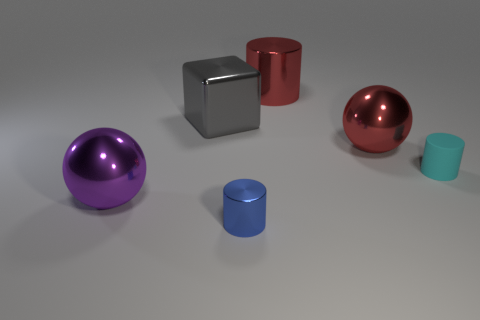What size is the metal sphere that is the same color as the large metallic cylinder?
Make the answer very short. Large. Is the number of rubber things left of the big purple sphere the same as the number of gray blocks to the right of the tiny cyan matte cylinder?
Provide a short and direct response. Yes. What is the size of the metallic ball that is to the right of the tiny blue metal object?
Your response must be concise. Large. The small thing that is behind the tiny blue cylinder that is in front of the large purple metallic thing is made of what material?
Provide a succinct answer. Rubber. What number of large red balls are in front of the big sphere that is behind the metal ball in front of the small cyan thing?
Ensure brevity in your answer.  0. Do the small cylinder that is left of the large red ball and the large ball behind the large purple metal ball have the same material?
Offer a very short reply. Yes. How many tiny blue things are the same shape as the tiny cyan rubber object?
Provide a short and direct response. 1. Is the number of metal balls that are right of the large cylinder greater than the number of small balls?
Your answer should be very brief. Yes. There is a large metallic object in front of the sphere that is right of the big ball that is in front of the small matte object; what is its shape?
Provide a short and direct response. Sphere. Is the shape of the tiny object that is behind the purple sphere the same as the small thing that is on the left side of the cyan object?
Your response must be concise. Yes. 